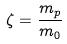Convert formula to latex. <formula><loc_0><loc_0><loc_500><loc_500>\zeta = \frac { m _ { p } } { m _ { 0 } }</formula> 